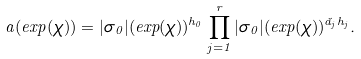<formula> <loc_0><loc_0><loc_500><loc_500>a ( e x p ( \chi ) ) = | \sigma _ { 0 } | ( e x p ( \chi ) ) ^ { h _ { 0 } } \prod _ { j = 1 } ^ { r } | \sigma _ { 0 } | ( e x p ( \chi ) ) ^ { \check { a } _ { j } h _ { j } } .</formula> 